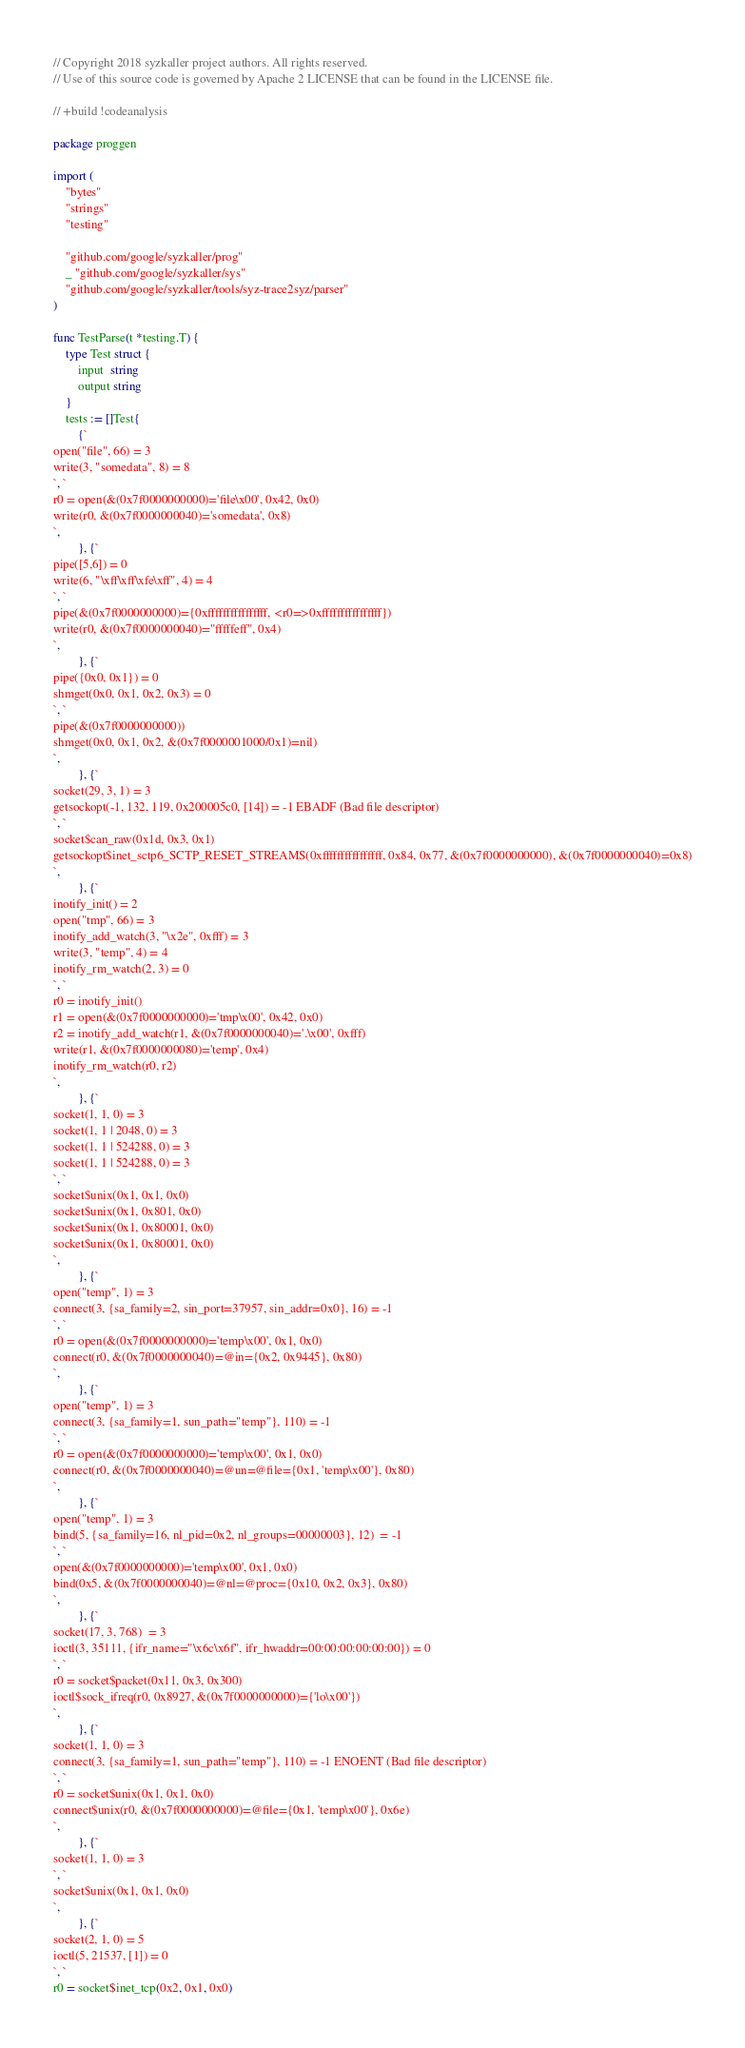Convert code to text. <code><loc_0><loc_0><loc_500><loc_500><_Go_>// Copyright 2018 syzkaller project authors. All rights reserved.
// Use of this source code is governed by Apache 2 LICENSE that can be found in the LICENSE file.

// +build !codeanalysis

package proggen

import (
	"bytes"
	"strings"
	"testing"

	"github.com/google/syzkaller/prog"
	_ "github.com/google/syzkaller/sys"
	"github.com/google/syzkaller/tools/syz-trace2syz/parser"
)

func TestParse(t *testing.T) {
	type Test struct {
		input  string
		output string
	}
	tests := []Test{
		{`
open("file", 66) = 3
write(3, "somedata", 8) = 8
`, `
r0 = open(&(0x7f0000000000)='file\x00', 0x42, 0x0)
write(r0, &(0x7f0000000040)='somedata', 0x8)
`,
		}, {`
pipe([5,6]) = 0
write(6, "\xff\xff\xfe\xff", 4) = 4
`, `
pipe(&(0x7f0000000000)={0xffffffffffffffff, <r0=>0xffffffffffffffff})
write(r0, &(0x7f0000000040)="fffffeff", 0x4)
`,
		}, {`
pipe({0x0, 0x1}) = 0
shmget(0x0, 0x1, 0x2, 0x3) = 0
`, `
pipe(&(0x7f0000000000))
shmget(0x0, 0x1, 0x2, &(0x7f0000001000/0x1)=nil)
`,
		}, {`
socket(29, 3, 1) = 3
getsockopt(-1, 132, 119, 0x200005c0, [14]) = -1 EBADF (Bad file descriptor)
`, `
socket$can_raw(0x1d, 0x3, 0x1)
getsockopt$inet_sctp6_SCTP_RESET_STREAMS(0xffffffffffffffff, 0x84, 0x77, &(0x7f0000000000), &(0x7f0000000040)=0x8)
`,
		}, {`
inotify_init() = 2
open("tmp", 66) = 3
inotify_add_watch(3, "\x2e", 0xfff) = 3
write(3, "temp", 4) = 4
inotify_rm_watch(2, 3) = 0
`, `
r0 = inotify_init()
r1 = open(&(0x7f0000000000)='tmp\x00', 0x42, 0x0)
r2 = inotify_add_watch(r1, &(0x7f0000000040)='.\x00', 0xfff)
write(r1, &(0x7f0000000080)='temp', 0x4)
inotify_rm_watch(r0, r2)
`,
		}, {`
socket(1, 1, 0) = 3
socket(1, 1 | 2048, 0) = 3
socket(1, 1 | 524288, 0) = 3
socket(1, 1 | 524288, 0) = 3
`, `
socket$unix(0x1, 0x1, 0x0)
socket$unix(0x1, 0x801, 0x0)
socket$unix(0x1, 0x80001, 0x0)
socket$unix(0x1, 0x80001, 0x0)
`,
		}, {`
open("temp", 1) = 3
connect(3, {sa_family=2, sin_port=37957, sin_addr=0x0}, 16) = -1
`, `
r0 = open(&(0x7f0000000000)='temp\x00', 0x1, 0x0)
connect(r0, &(0x7f0000000040)=@in={0x2, 0x9445}, 0x80)
`,
		}, {`
open("temp", 1) = 3
connect(3, {sa_family=1, sun_path="temp"}, 110) = -1
`, `
r0 = open(&(0x7f0000000000)='temp\x00', 0x1, 0x0)
connect(r0, &(0x7f0000000040)=@un=@file={0x1, 'temp\x00'}, 0x80)
`,
		}, {`
open("temp", 1) = 3
bind(5, {sa_family=16, nl_pid=0x2, nl_groups=00000003}, 12)  = -1
`, `
open(&(0x7f0000000000)='temp\x00', 0x1, 0x0)
bind(0x5, &(0x7f0000000040)=@nl=@proc={0x10, 0x2, 0x3}, 0x80)
`,
		}, {`
socket(17, 3, 768)  = 3
ioctl(3, 35111, {ifr_name="\x6c\x6f", ifr_hwaddr=00:00:00:00:00:00}) = 0
`, `
r0 = socket$packet(0x11, 0x3, 0x300)
ioctl$sock_ifreq(r0, 0x8927, &(0x7f0000000000)={'lo\x00'})
`,
		}, {`
socket(1, 1, 0) = 3
connect(3, {sa_family=1, sun_path="temp"}, 110) = -1 ENOENT (Bad file descriptor)
`, `
r0 = socket$unix(0x1, 0x1, 0x0)
connect$unix(r0, &(0x7f0000000000)=@file={0x1, 'temp\x00'}, 0x6e)
`,
		}, {`
socket(1, 1, 0) = 3
`, `
socket$unix(0x1, 0x1, 0x0)
`,
		}, {`
socket(2, 1, 0) = 5
ioctl(5, 21537, [1]) = 0
`, `
r0 = socket$inet_tcp(0x2, 0x1, 0x0)</code> 